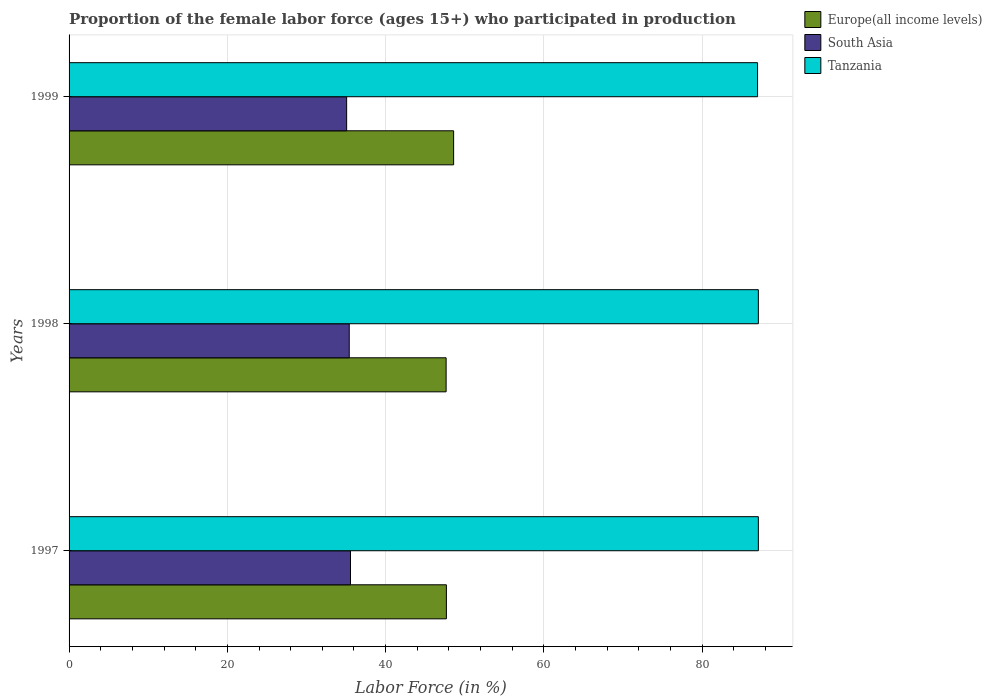How many different coloured bars are there?
Provide a short and direct response. 3. How many groups of bars are there?
Your response must be concise. 3. Are the number of bars per tick equal to the number of legend labels?
Your response must be concise. Yes. How many bars are there on the 3rd tick from the top?
Offer a very short reply. 3. What is the label of the 1st group of bars from the top?
Make the answer very short. 1999. What is the proportion of the female labor force who participated in production in Europe(all income levels) in 1999?
Make the answer very short. 48.59. Across all years, what is the maximum proportion of the female labor force who participated in production in Tanzania?
Keep it short and to the point. 87.1. What is the total proportion of the female labor force who participated in production in Tanzania in the graph?
Ensure brevity in your answer.  261.2. What is the difference between the proportion of the female labor force who participated in production in Europe(all income levels) in 1997 and that in 1998?
Provide a succinct answer. 0.03. What is the difference between the proportion of the female labor force who participated in production in South Asia in 1997 and the proportion of the female labor force who participated in production in Tanzania in 1999?
Give a very brief answer. -51.44. What is the average proportion of the female labor force who participated in production in South Asia per year?
Your response must be concise. 35.35. In the year 1999, what is the difference between the proportion of the female labor force who participated in production in South Asia and proportion of the female labor force who participated in production in Tanzania?
Your answer should be very brief. -51.93. What is the ratio of the proportion of the female labor force who participated in production in South Asia in 1997 to that in 1999?
Provide a succinct answer. 1.01. What is the difference between the highest and the second highest proportion of the female labor force who participated in production in Tanzania?
Your answer should be compact. 0. What is the difference between the highest and the lowest proportion of the female labor force who participated in production in Europe(all income levels)?
Your answer should be compact. 0.95. What does the 1st bar from the bottom in 1998 represents?
Offer a very short reply. Europe(all income levels). How many bars are there?
Your answer should be compact. 9. Are all the bars in the graph horizontal?
Give a very brief answer. Yes. What is the difference between two consecutive major ticks on the X-axis?
Make the answer very short. 20. Does the graph contain any zero values?
Your answer should be compact. No. Where does the legend appear in the graph?
Offer a very short reply. Top right. How many legend labels are there?
Offer a very short reply. 3. How are the legend labels stacked?
Offer a terse response. Vertical. What is the title of the graph?
Keep it short and to the point. Proportion of the female labor force (ages 15+) who participated in production. What is the Labor Force (in %) in Europe(all income levels) in 1997?
Your answer should be compact. 47.68. What is the Labor Force (in %) of South Asia in 1997?
Provide a succinct answer. 35.56. What is the Labor Force (in %) of Tanzania in 1997?
Ensure brevity in your answer.  87.1. What is the Labor Force (in %) in Europe(all income levels) in 1998?
Your answer should be compact. 47.65. What is the Labor Force (in %) in South Asia in 1998?
Your answer should be very brief. 35.4. What is the Labor Force (in %) of Tanzania in 1998?
Your response must be concise. 87.1. What is the Labor Force (in %) in Europe(all income levels) in 1999?
Offer a terse response. 48.59. What is the Labor Force (in %) in South Asia in 1999?
Give a very brief answer. 35.07. Across all years, what is the maximum Labor Force (in %) of Europe(all income levels)?
Make the answer very short. 48.59. Across all years, what is the maximum Labor Force (in %) of South Asia?
Your response must be concise. 35.56. Across all years, what is the maximum Labor Force (in %) of Tanzania?
Make the answer very short. 87.1. Across all years, what is the minimum Labor Force (in %) in Europe(all income levels)?
Your response must be concise. 47.65. Across all years, what is the minimum Labor Force (in %) in South Asia?
Offer a terse response. 35.07. Across all years, what is the minimum Labor Force (in %) in Tanzania?
Make the answer very short. 87. What is the total Labor Force (in %) of Europe(all income levels) in the graph?
Provide a succinct answer. 143.92. What is the total Labor Force (in %) of South Asia in the graph?
Ensure brevity in your answer.  106.04. What is the total Labor Force (in %) in Tanzania in the graph?
Your answer should be very brief. 261.2. What is the difference between the Labor Force (in %) of Europe(all income levels) in 1997 and that in 1998?
Give a very brief answer. 0.04. What is the difference between the Labor Force (in %) of South Asia in 1997 and that in 1998?
Your response must be concise. 0.16. What is the difference between the Labor Force (in %) of Europe(all income levels) in 1997 and that in 1999?
Ensure brevity in your answer.  -0.91. What is the difference between the Labor Force (in %) of South Asia in 1997 and that in 1999?
Keep it short and to the point. 0.49. What is the difference between the Labor Force (in %) of Tanzania in 1997 and that in 1999?
Give a very brief answer. 0.1. What is the difference between the Labor Force (in %) of Europe(all income levels) in 1998 and that in 1999?
Your response must be concise. -0.95. What is the difference between the Labor Force (in %) in South Asia in 1998 and that in 1999?
Your answer should be very brief. 0.33. What is the difference between the Labor Force (in %) of Tanzania in 1998 and that in 1999?
Your answer should be very brief. 0.1. What is the difference between the Labor Force (in %) in Europe(all income levels) in 1997 and the Labor Force (in %) in South Asia in 1998?
Give a very brief answer. 12.28. What is the difference between the Labor Force (in %) in Europe(all income levels) in 1997 and the Labor Force (in %) in Tanzania in 1998?
Your response must be concise. -39.42. What is the difference between the Labor Force (in %) in South Asia in 1997 and the Labor Force (in %) in Tanzania in 1998?
Keep it short and to the point. -51.54. What is the difference between the Labor Force (in %) in Europe(all income levels) in 1997 and the Labor Force (in %) in South Asia in 1999?
Your response must be concise. 12.61. What is the difference between the Labor Force (in %) in Europe(all income levels) in 1997 and the Labor Force (in %) in Tanzania in 1999?
Make the answer very short. -39.32. What is the difference between the Labor Force (in %) in South Asia in 1997 and the Labor Force (in %) in Tanzania in 1999?
Make the answer very short. -51.44. What is the difference between the Labor Force (in %) in Europe(all income levels) in 1998 and the Labor Force (in %) in South Asia in 1999?
Provide a succinct answer. 12.57. What is the difference between the Labor Force (in %) of Europe(all income levels) in 1998 and the Labor Force (in %) of Tanzania in 1999?
Provide a succinct answer. -39.35. What is the difference between the Labor Force (in %) in South Asia in 1998 and the Labor Force (in %) in Tanzania in 1999?
Provide a short and direct response. -51.6. What is the average Labor Force (in %) of Europe(all income levels) per year?
Keep it short and to the point. 47.97. What is the average Labor Force (in %) of South Asia per year?
Provide a short and direct response. 35.35. What is the average Labor Force (in %) of Tanzania per year?
Your response must be concise. 87.07. In the year 1997, what is the difference between the Labor Force (in %) of Europe(all income levels) and Labor Force (in %) of South Asia?
Your answer should be compact. 12.12. In the year 1997, what is the difference between the Labor Force (in %) in Europe(all income levels) and Labor Force (in %) in Tanzania?
Provide a succinct answer. -39.42. In the year 1997, what is the difference between the Labor Force (in %) of South Asia and Labor Force (in %) of Tanzania?
Your answer should be compact. -51.54. In the year 1998, what is the difference between the Labor Force (in %) of Europe(all income levels) and Labor Force (in %) of South Asia?
Your response must be concise. 12.24. In the year 1998, what is the difference between the Labor Force (in %) of Europe(all income levels) and Labor Force (in %) of Tanzania?
Offer a terse response. -39.45. In the year 1998, what is the difference between the Labor Force (in %) of South Asia and Labor Force (in %) of Tanzania?
Your answer should be compact. -51.7. In the year 1999, what is the difference between the Labor Force (in %) of Europe(all income levels) and Labor Force (in %) of South Asia?
Offer a terse response. 13.52. In the year 1999, what is the difference between the Labor Force (in %) in Europe(all income levels) and Labor Force (in %) in Tanzania?
Keep it short and to the point. -38.41. In the year 1999, what is the difference between the Labor Force (in %) of South Asia and Labor Force (in %) of Tanzania?
Your response must be concise. -51.93. What is the ratio of the Labor Force (in %) in Europe(all income levels) in 1997 to that in 1998?
Your answer should be very brief. 1. What is the ratio of the Labor Force (in %) of Europe(all income levels) in 1997 to that in 1999?
Keep it short and to the point. 0.98. What is the ratio of the Labor Force (in %) in South Asia in 1997 to that in 1999?
Offer a terse response. 1.01. What is the ratio of the Labor Force (in %) in Tanzania in 1997 to that in 1999?
Make the answer very short. 1. What is the ratio of the Labor Force (in %) of Europe(all income levels) in 1998 to that in 1999?
Your answer should be very brief. 0.98. What is the ratio of the Labor Force (in %) in South Asia in 1998 to that in 1999?
Provide a short and direct response. 1.01. What is the difference between the highest and the second highest Labor Force (in %) in Europe(all income levels)?
Provide a short and direct response. 0.91. What is the difference between the highest and the second highest Labor Force (in %) in South Asia?
Your answer should be very brief. 0.16. What is the difference between the highest and the second highest Labor Force (in %) of Tanzania?
Ensure brevity in your answer.  0. What is the difference between the highest and the lowest Labor Force (in %) in Europe(all income levels)?
Provide a succinct answer. 0.95. What is the difference between the highest and the lowest Labor Force (in %) in South Asia?
Keep it short and to the point. 0.49. 